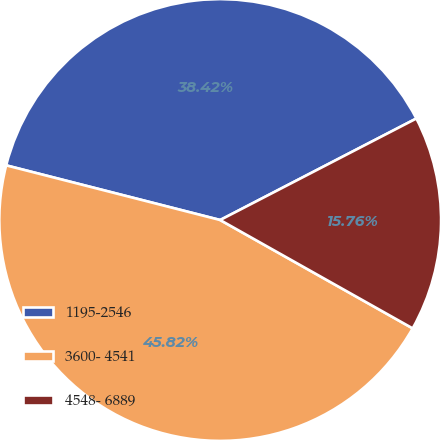Convert chart. <chart><loc_0><loc_0><loc_500><loc_500><pie_chart><fcel>1195-2546<fcel>3600- 4541<fcel>4548- 6889<nl><fcel>38.42%<fcel>45.82%<fcel>15.76%<nl></chart> 